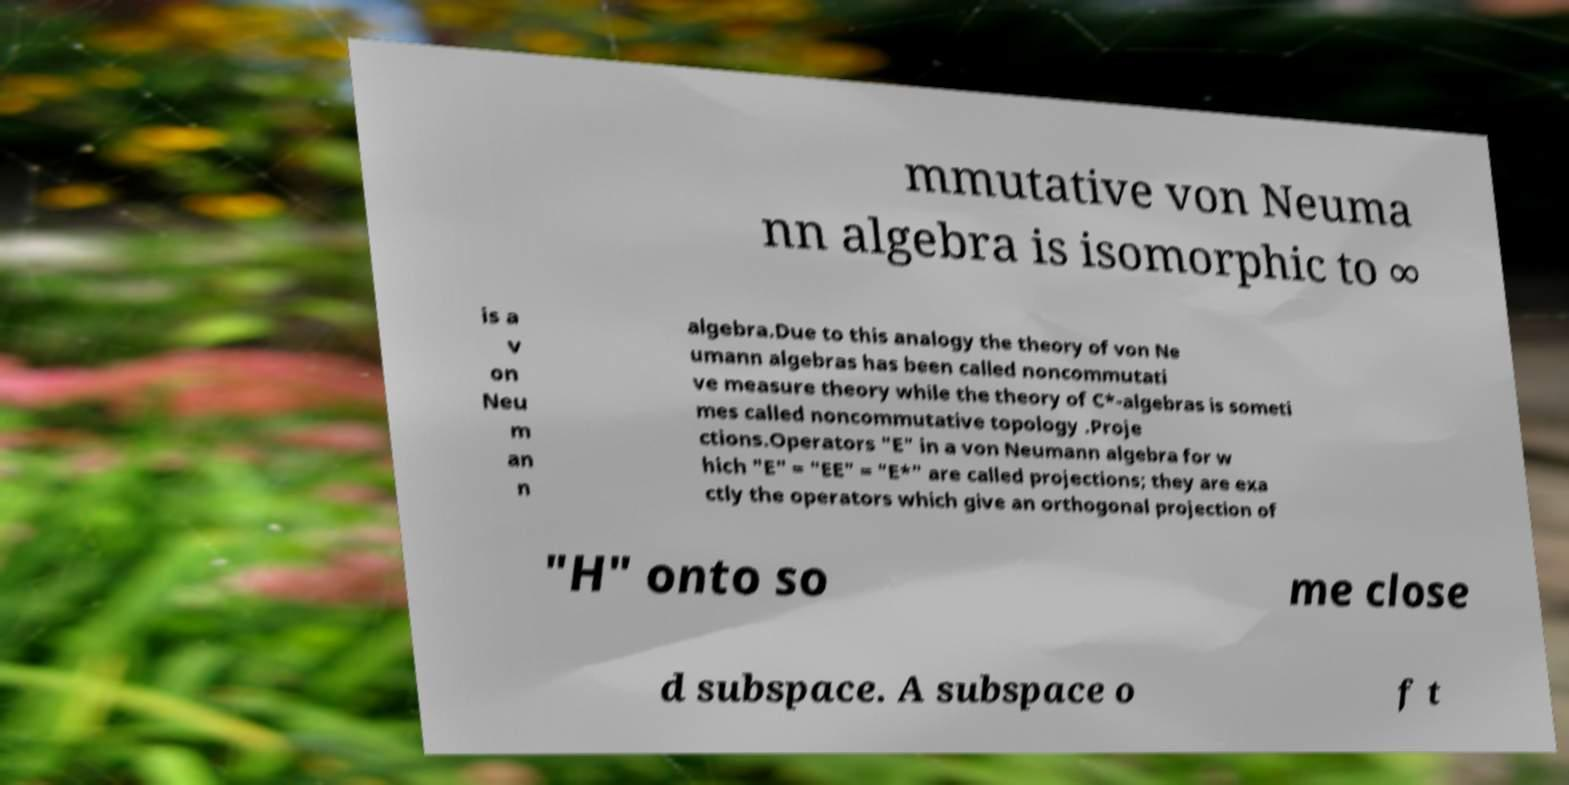Please identify and transcribe the text found in this image. mmutative von Neuma nn algebra is isomorphic to ∞ is a v on Neu m an n algebra.Due to this analogy the theory of von Ne umann algebras has been called noncommutati ve measure theory while the theory of C*-algebras is someti mes called noncommutative topology .Proje ctions.Operators "E" in a von Neumann algebra for w hich "E" = "EE" = "E*" are called projections; they are exa ctly the operators which give an orthogonal projection of "H" onto so me close d subspace. A subspace o f t 